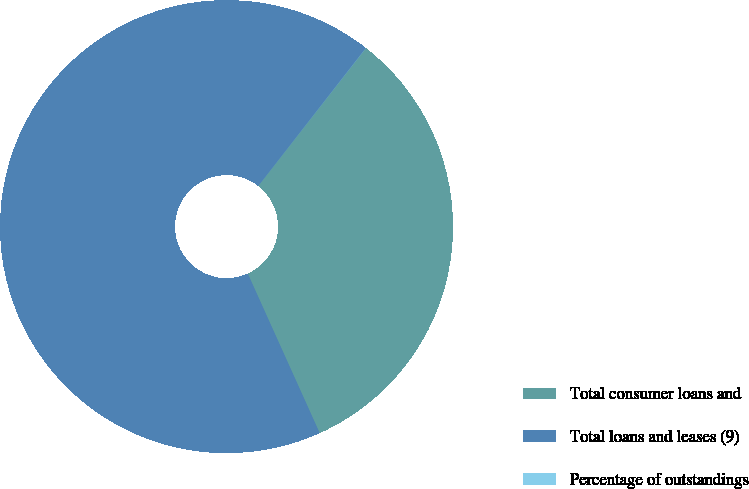Convert chart to OTSL. <chart><loc_0><loc_0><loc_500><loc_500><pie_chart><fcel>Total consumer loans and<fcel>Total loans and leases (9)<fcel>Percentage of outstandings<nl><fcel>32.7%<fcel>67.29%<fcel>0.01%<nl></chart> 